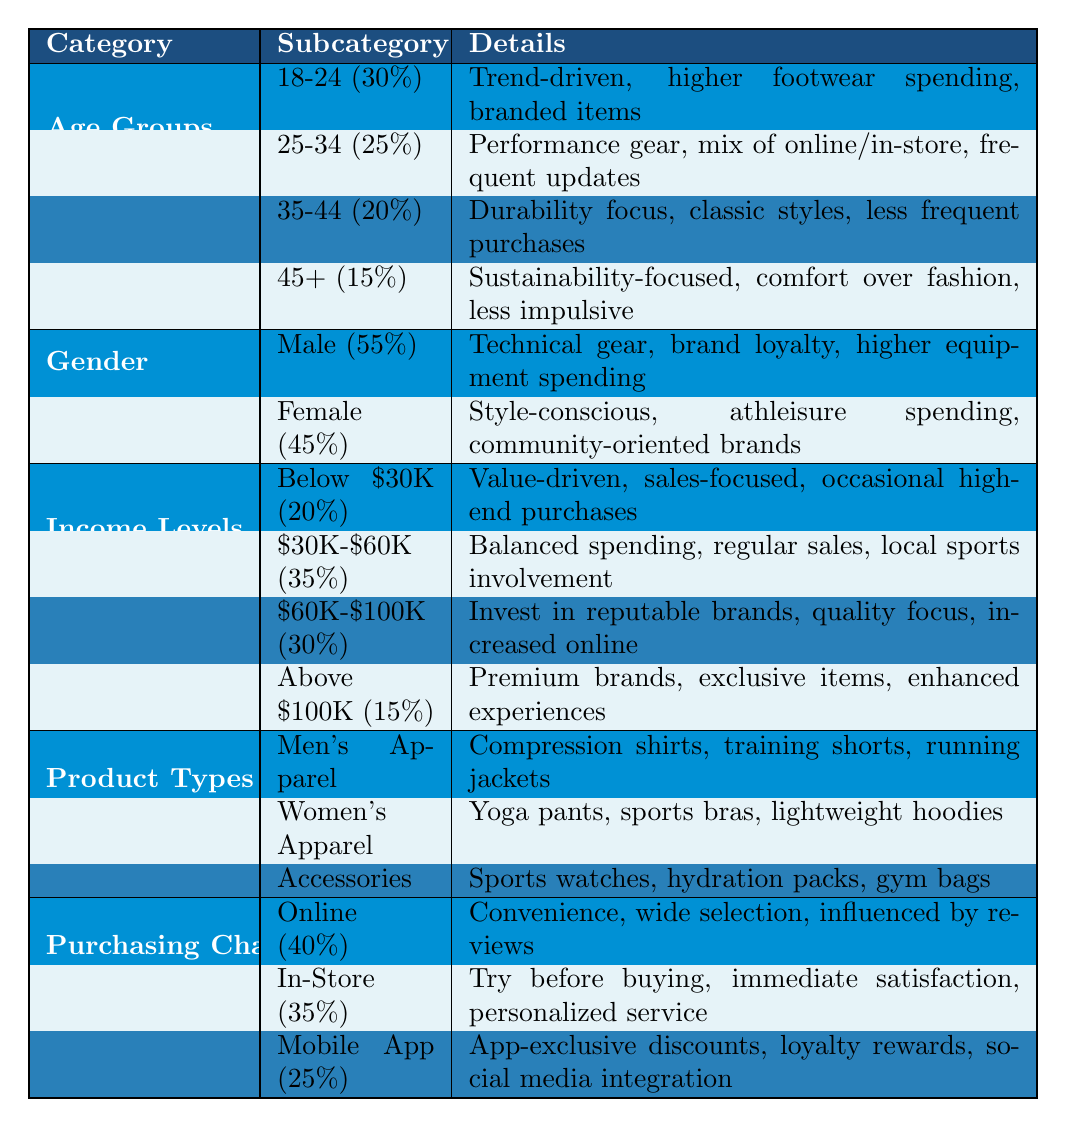What percentage of customers are aged 18-24? According to the table under the Age Groups section, the percentage for the 18-24 age group is explicitly stated as 30%
Answer: 30% What are the best-selling women's apparel items? The table lists the best-selling items for women's apparel, which are yoga pants, sports bras, and lightweight hoodies
Answer: Yoga pants, sports bras, and lightweight hoodies Which income level group has the highest percentage? The income levels section shows that the $30K-$60K group has the highest percentage at 35%
Answer: $30K-$60K Is the majority of customers male or female? The Gender section indicates that 55% of customers are male, while 45% are female, indicating the majority are male
Answer: Yes, the majority are male What is the total percentage of online and mobile app purchasing channels? The percentages for online and mobile app are 40% and 25%, respectively. Adding them gives 40 + 25 = 65% for both channels combined
Answer: 65% Which age group focuses on sustainability in their buying patterns? The 45+ age group is noted for being sustainability-focused in their buying patterns according to the Age Groups section
Answer: 45+ What is the common buying pattern for the 25-34 age group? This age group is recognized for investing in performance gear, having a mix of online and in-store shopping, and frequently updating their wardrobe
Answer: Invest in performance gear, mix of online and in-store, frequent updates Is there a notable difference in purchasing preferences between genders? Yes, males tend to purchase more technical gear and engage with brand loyalty, while females are more style-conscious and spend more on athleisure
Answer: Yes, there is a notable difference What product type has the least number of best-selling items listed? The Accessories section lists popular items but does not have a separate category for best-sellers like the Apparel sections do, indicating fewer specific best-selling items
Answer: Accessories have the least number listed What percentage of customers prefer to shop online? The table specifies that 40% of customers prefer to shop online, highlighting this as the most popular channel
Answer: 40% 